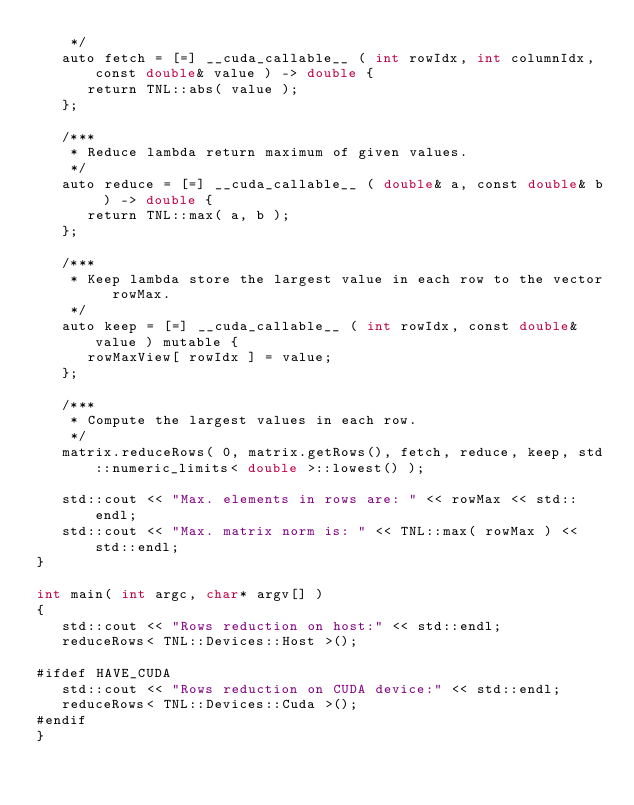<code> <loc_0><loc_0><loc_500><loc_500><_Cuda_>    */
   auto fetch = [=] __cuda_callable__ ( int rowIdx, int columnIdx, const double& value ) -> double {
      return TNL::abs( value );
   };

   /***
    * Reduce lambda return maximum of given values.
    */
   auto reduce = [=] __cuda_callable__ ( double& a, const double& b ) -> double {
      return TNL::max( a, b );
   };

   /***
    * Keep lambda store the largest value in each row to the vector rowMax.
    */
   auto keep = [=] __cuda_callable__ ( int rowIdx, const double& value ) mutable {
      rowMaxView[ rowIdx ] = value;
   };

   /***
    * Compute the largest values in each row.
    */
   matrix.reduceRows( 0, matrix.getRows(), fetch, reduce, keep, std::numeric_limits< double >::lowest() );

   std::cout << "Max. elements in rows are: " << rowMax << std::endl;
   std::cout << "Max. matrix norm is: " << TNL::max( rowMax ) << std::endl;
}

int main( int argc, char* argv[] )
{
   std::cout << "Rows reduction on host:" << std::endl;
   reduceRows< TNL::Devices::Host >();

#ifdef HAVE_CUDA
   std::cout << "Rows reduction on CUDA device:" << std::endl;
   reduceRows< TNL::Devices::Cuda >();
#endif
}
</code> 